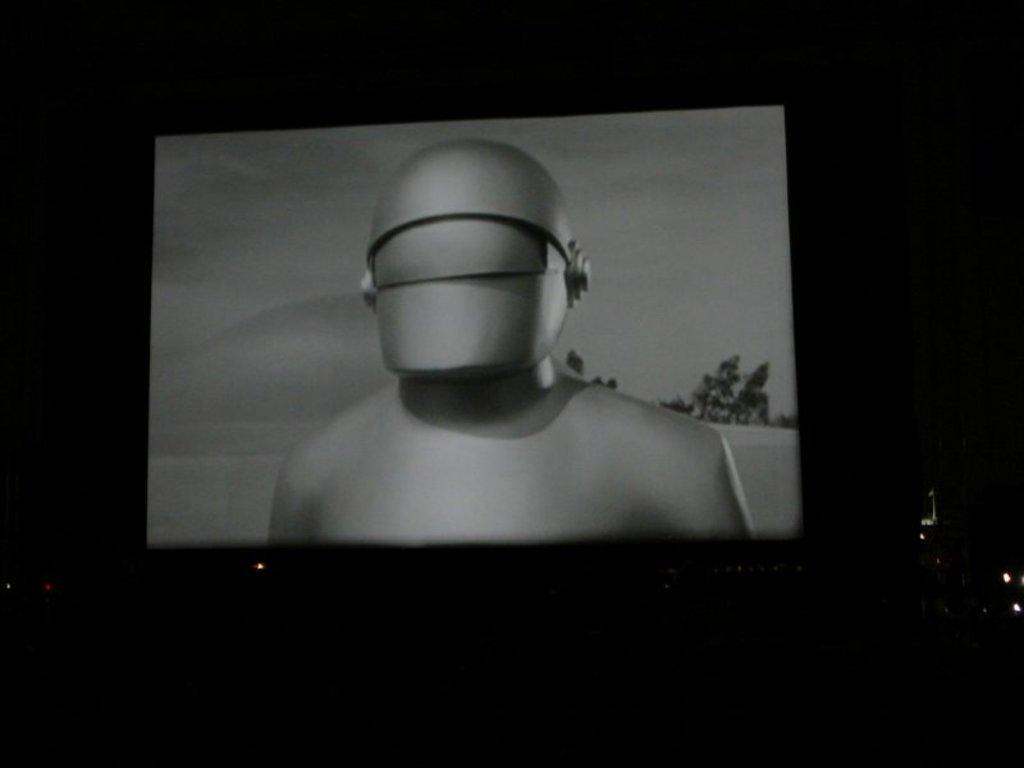In one or two sentences, can you explain what this image depicts? In this image we can see an old movie is playing in the theater. 